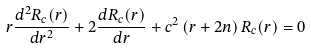Convert formula to latex. <formula><loc_0><loc_0><loc_500><loc_500>r \frac { d ^ { 2 } R _ { c } ( r ) } { d r ^ { 2 } } + 2 \frac { d R _ { c } ( r ) } { d r } + c ^ { 2 } \left ( r + 2 n \right ) R _ { c } ( r ) = 0</formula> 